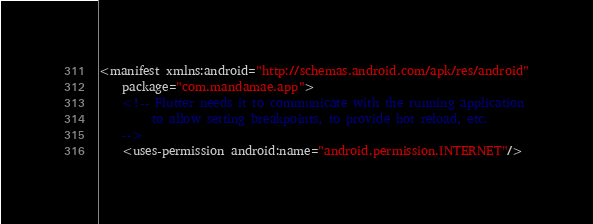Convert code to text. <code><loc_0><loc_0><loc_500><loc_500><_XML_><manifest xmlns:android="http://schemas.android.com/apk/res/android"
    package="com.mandamae.app">
    <!-- Flutter needs it to communicate with the running application
         to allow setting breakpoints, to provide hot reload, etc.
    -->
    <uses-permission android:name="android.permission.INTERNET"/></code> 